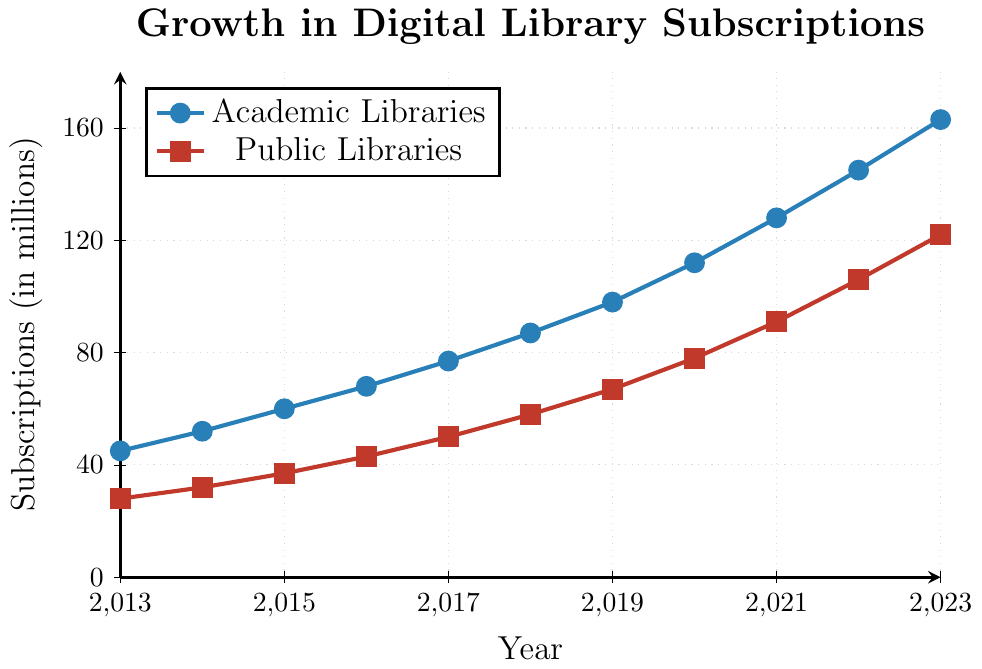What's the difference in subscriptions between academic libraries and public libraries in 2023? To find the difference, locate the subscription values for 2023: academic libraries have 163 subscriptions and public libraries have 122 subscriptions. Subtract the smaller value from the larger value: 163 - 122 = 41.
Answer: 41 Which type of library saw higher growth in subscriptions from 2016 to 2020? Look at the values for both academic and public libraries in 2016 and 2020: Academic libraries went from 68 to 112 (growth of 112 - 68 = 44), and public libraries went from 43 to 78 (growth of 78 - 43 = 35). Compare the two growth values.
Answer: Academic Libraries How many total subscriptions were there for academic and public libraries combined in 2018? Find the subscriptions for academic and public libraries in 2018: academic libraries had 87, and public libraries had 58. Add these values together: 87 + 58 = 145.
Answer: 145 In which year did subscriptions for academic libraries surpass 100? Observe the trend for academic libraries and identify the year when subscriptions exceeded 100. In 2019, subscriptions were 98, and in 2020, they were 112. Thus, 2020 is the year when subscriptions surpassed 100.
Answer: 2020 What is the average annual increase in subscriptions for public libraries from 2013 to 2018? Identify the values for public libraries in 2013 (28) and 2018 (58). The total increase over the five years is 58 - 28 = 30. The average annual increase is then 30 / 5 = 6.
Answer: 6 Which year had the smallest difference in subscriptions between academic and public libraries? Calculate the annual differences between academic and public libraries. The smallest difference happens in 2013 (45 - 28 = 17). Comparing other years, 2013 has the smallest difference: 2014 (20), 2015 (23), 2016 (25), 2017 (27), 2018 (29), 2019 (31), 2020 (34), 2021 (37), 2022 (39), 2023 (41).
Answer: 2013 What is the trend in digital library subscriptions for academic libraries over the decade? Observing each year, the subscription count for academic libraries steadily increases from 45 in 2013 to 163 in 2023. This indicates a consistent upward trend.
Answer: Upward trend By how much did academic library subscriptions increase from 2017 to 2023? Locate the subscription values for academic libraries in 2017 (77) and 2023 (163). Calculate the increase: 163 - 77 = 86.
Answer: 86 